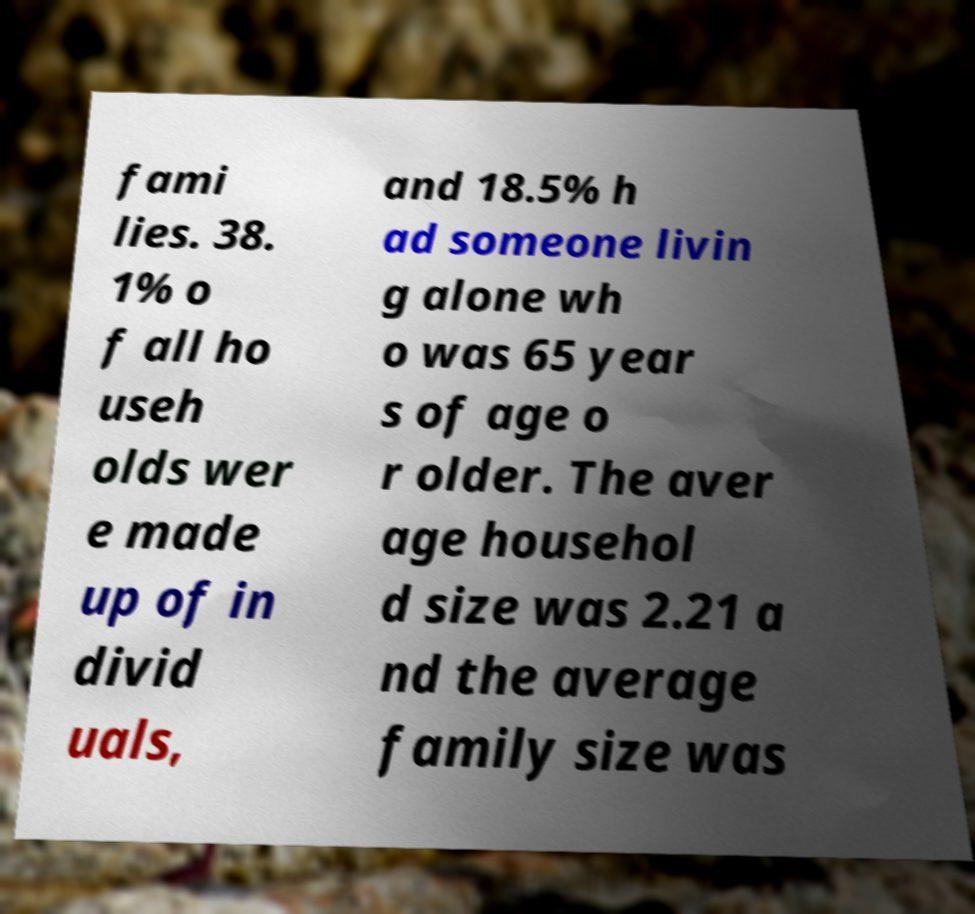What messages or text are displayed in this image? I need them in a readable, typed format. fami lies. 38. 1% o f all ho useh olds wer e made up of in divid uals, and 18.5% h ad someone livin g alone wh o was 65 year s of age o r older. The aver age househol d size was 2.21 a nd the average family size was 